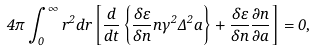<formula> <loc_0><loc_0><loc_500><loc_500>4 \pi \int _ { 0 } ^ { \infty } r ^ { 2 } d r \left [ \frac { d } { d t } \left \{ \frac { \delta \varepsilon } { \delta n } n \gamma ^ { 2 } \Delta ^ { 2 } \dot { a } \right \} + \frac { \delta \varepsilon } { \delta n } \frac { \partial n } { \partial a } \right ] = 0 ,</formula> 